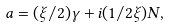<formula> <loc_0><loc_0><loc_500><loc_500>a = ( \xi / 2 ) \gamma + i ( 1 / 2 \xi ) N ,</formula> 